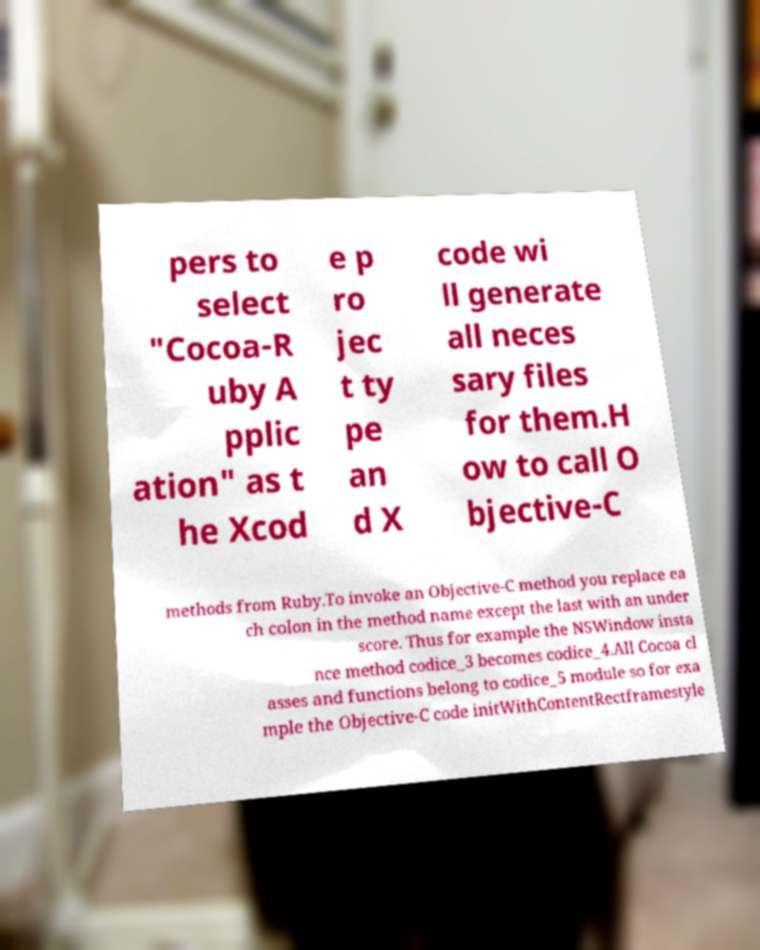For documentation purposes, I need the text within this image transcribed. Could you provide that? pers to select "Cocoa-R uby A pplic ation" as t he Xcod e p ro jec t ty pe an d X code wi ll generate all neces sary files for them.H ow to call O bjective-C methods from Ruby.To invoke an Objective-C method you replace ea ch colon in the method name except the last with an under score. Thus for example the NSWindow insta nce method codice_3 becomes codice_4.All Cocoa cl asses and functions belong to codice_5 module so for exa mple the Objective-C code initWithContentRectframestyle 